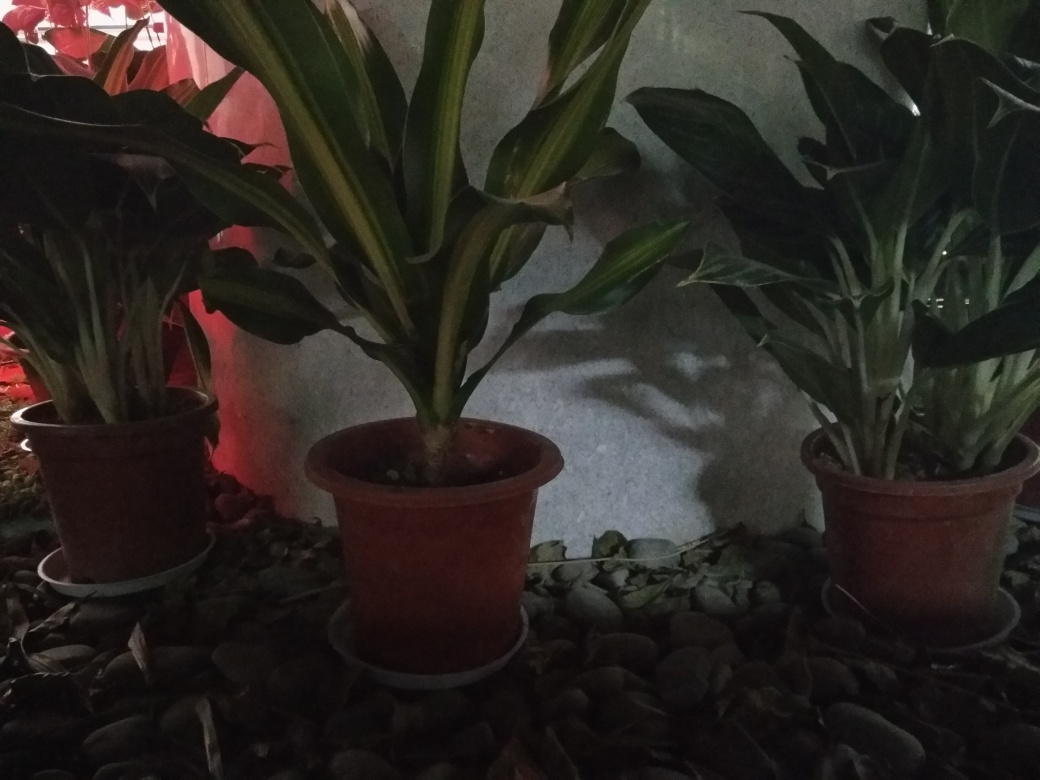What can you infer about the location where this photo was taken? Based on the plants being in pots and the presence of pebbles, it suggests the photo was taken in a domestic indoor or semi-outdoor environment like a patio or an interior designed with nature elements. The presence of the protective saucers under the pots indicate care for preventing water damage to the surface beneath. 